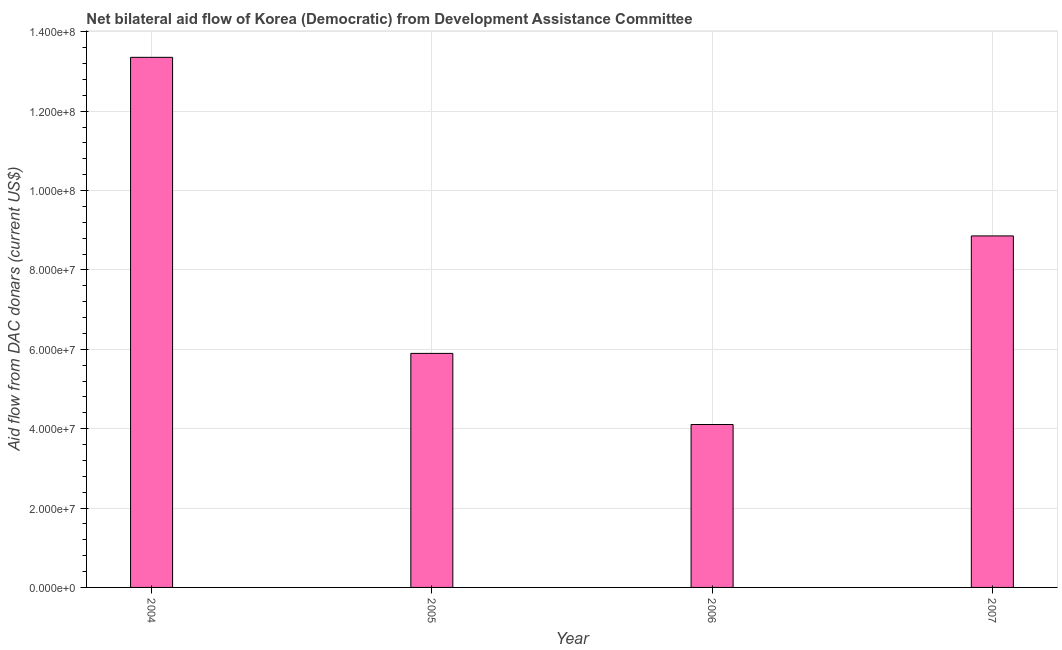Does the graph contain any zero values?
Your response must be concise. No. Does the graph contain grids?
Ensure brevity in your answer.  Yes. What is the title of the graph?
Give a very brief answer. Net bilateral aid flow of Korea (Democratic) from Development Assistance Committee. What is the label or title of the Y-axis?
Offer a very short reply. Aid flow from DAC donars (current US$). What is the net bilateral aid flows from dac donors in 2005?
Provide a short and direct response. 5.90e+07. Across all years, what is the maximum net bilateral aid flows from dac donors?
Your response must be concise. 1.34e+08. Across all years, what is the minimum net bilateral aid flows from dac donors?
Your response must be concise. 4.10e+07. In which year was the net bilateral aid flows from dac donors minimum?
Your answer should be compact. 2006. What is the sum of the net bilateral aid flows from dac donors?
Your answer should be compact. 3.22e+08. What is the difference between the net bilateral aid flows from dac donors in 2004 and 2006?
Provide a succinct answer. 9.25e+07. What is the average net bilateral aid flows from dac donors per year?
Offer a terse response. 8.05e+07. What is the median net bilateral aid flows from dac donors?
Your answer should be compact. 7.38e+07. What is the ratio of the net bilateral aid flows from dac donors in 2004 to that in 2006?
Your response must be concise. 3.25. Is the net bilateral aid flows from dac donors in 2006 less than that in 2007?
Give a very brief answer. Yes. What is the difference between the highest and the second highest net bilateral aid flows from dac donors?
Offer a terse response. 4.50e+07. Is the sum of the net bilateral aid flows from dac donors in 2004 and 2006 greater than the maximum net bilateral aid flows from dac donors across all years?
Your response must be concise. Yes. What is the difference between the highest and the lowest net bilateral aid flows from dac donors?
Provide a short and direct response. 9.25e+07. Are the values on the major ticks of Y-axis written in scientific E-notation?
Your response must be concise. Yes. What is the Aid flow from DAC donars (current US$) in 2004?
Offer a terse response. 1.34e+08. What is the Aid flow from DAC donars (current US$) in 2005?
Offer a very short reply. 5.90e+07. What is the Aid flow from DAC donars (current US$) in 2006?
Offer a very short reply. 4.10e+07. What is the Aid flow from DAC donars (current US$) of 2007?
Your response must be concise. 8.86e+07. What is the difference between the Aid flow from DAC donars (current US$) in 2004 and 2005?
Ensure brevity in your answer.  7.46e+07. What is the difference between the Aid flow from DAC donars (current US$) in 2004 and 2006?
Offer a terse response. 9.25e+07. What is the difference between the Aid flow from DAC donars (current US$) in 2004 and 2007?
Offer a very short reply. 4.50e+07. What is the difference between the Aid flow from DAC donars (current US$) in 2005 and 2006?
Your response must be concise. 1.79e+07. What is the difference between the Aid flow from DAC donars (current US$) in 2005 and 2007?
Provide a short and direct response. -2.96e+07. What is the difference between the Aid flow from DAC donars (current US$) in 2006 and 2007?
Provide a succinct answer. -4.75e+07. What is the ratio of the Aid flow from DAC donars (current US$) in 2004 to that in 2005?
Your response must be concise. 2.27. What is the ratio of the Aid flow from DAC donars (current US$) in 2004 to that in 2006?
Provide a short and direct response. 3.25. What is the ratio of the Aid flow from DAC donars (current US$) in 2004 to that in 2007?
Your answer should be very brief. 1.51. What is the ratio of the Aid flow from DAC donars (current US$) in 2005 to that in 2006?
Offer a terse response. 1.44. What is the ratio of the Aid flow from DAC donars (current US$) in 2005 to that in 2007?
Provide a succinct answer. 0.67. What is the ratio of the Aid flow from DAC donars (current US$) in 2006 to that in 2007?
Provide a short and direct response. 0.46. 